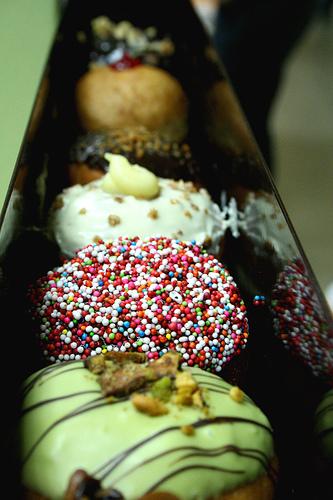How many donuts are pictured?
Keep it brief. 6. Are these items made with sugar usually?
Concise answer only. Yes. Are these items considered healthy food?
Give a very brief answer. No. 